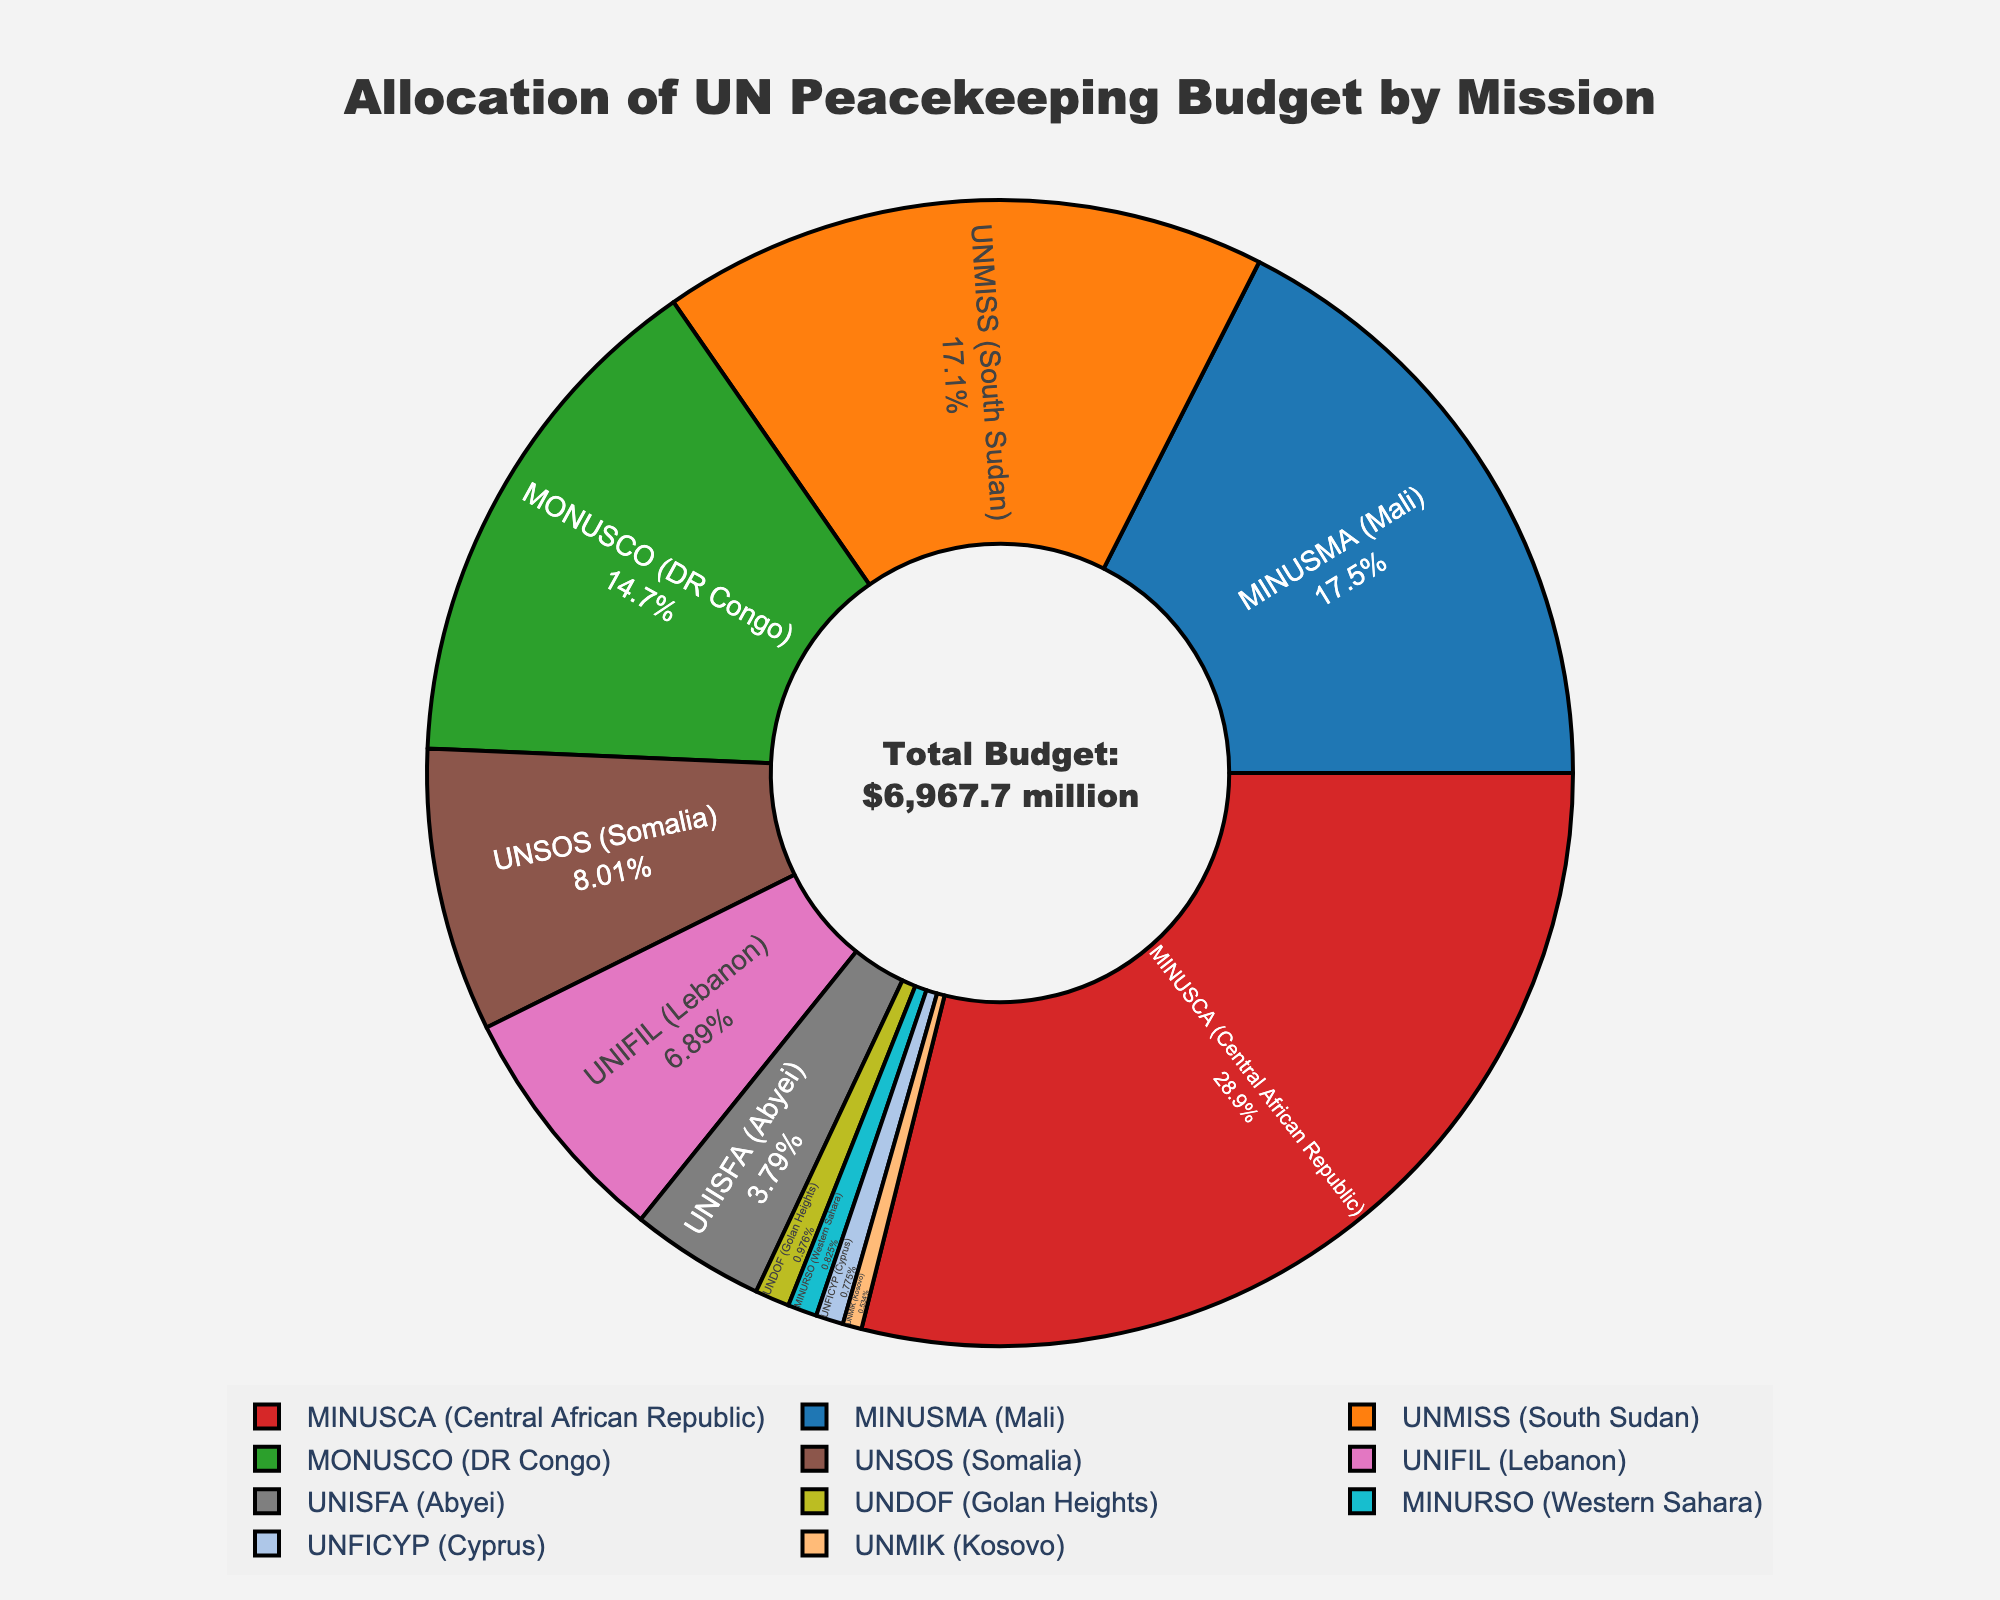What is the percentage of the budget allocated to the mission in Western Sahara? The mission in Western Sahara (MINURSO) has a budget allocation of $57.5 million. The total budget of all missions is $7,962.7 million. The percentage is calculated as (57.5 / 7962.7) * 100 ≈ 0.7%.
Answer: 0.7% Which mission has the largest budget allocation, and what is its percentage? The mission with the largest budget is MINUSMA (Mali) with a budget of $1,221.4 million. The total budget of all missions is $7,962.7 million. The percentage is calculated as (1221.4 / 7962.7) * 100 ≈ 15.3%.
Answer: MINUSMA (Mali), 15.3% What is the combined budget allocation for MINUSCA (Central African Republic) and MONUSCO (DR Congo)? The budget for MINUSCA is $1,006.4 million and for MONUSCO is $1,022.0 million. Their combined budget is calculated as 1006.4 + 1022.0 = 2028.4 million.
Answer: $2028.4 million Which mission has the smallest budget allocation? The mission with the smallest budget is UNMIK (Kosovo) with a budget of $37.2 million.
Answer: UNMIK (Kosovo) How does the budget for UNIFIL (Lebanon) compare to UNMISS (South Sudan)? The budget for UNIFIL is $480.0 million, and for UNMISS it is $1,192.8 million. UNMISS has a higher budget than UNIFIL with a difference of 1192.8 - 480.0 = 712.8 million.
Answer: UNMISS (higher by $712.8 million) Which color represents the mission in Cyprus? The mission in Cyprus (UNFICYP) is represented by a color that, based on the custom color scale order, appears to be at the seventh position, typically a light purple.
Answer: Light Purple What percentage of the budget is allocated to missions in Africa, considering MINUSCA, MINUSMA, MONUSCO, UNMISS, and UNSOS? The total budget for those missions is MINUSCA ($1006.4M) + MINUSMA ($1221.4M) + MONUSCO ($1022.0M) + UNMISS ($1192.8M) + UNSOS ($558.1M) = $5000.7 million. The percentage is calculated as (5000.7 / 7962.7) * 100 ≈ 62.8%.
Answer: 62.8% What is the total budget allocated to the missions outside Africa? The budgets for the missions outside Africa are UNIFIL ($480.0M), MINURSO ($57.5M), UNFICYP ($54.0M), UNDOF ($68.0M), UNMIK ($37.2M), and the total is $480.0 + 57.5 + 54.0 + 68.0 + 37.2 = $696.7 million.
Answer: $696.7 million How does the budget allocation for the mission in the Golan Heights (UNDOF) compare to the mission in Abyei (UNISFA)? The budget for UNDOF is $68.0 million, while for UNISFA it is $263.9 million. UNISFA's budget is larger by 263.9 - 68.0 = $195.9 million.
Answer: UNISFA (higher by $195.9 million) 